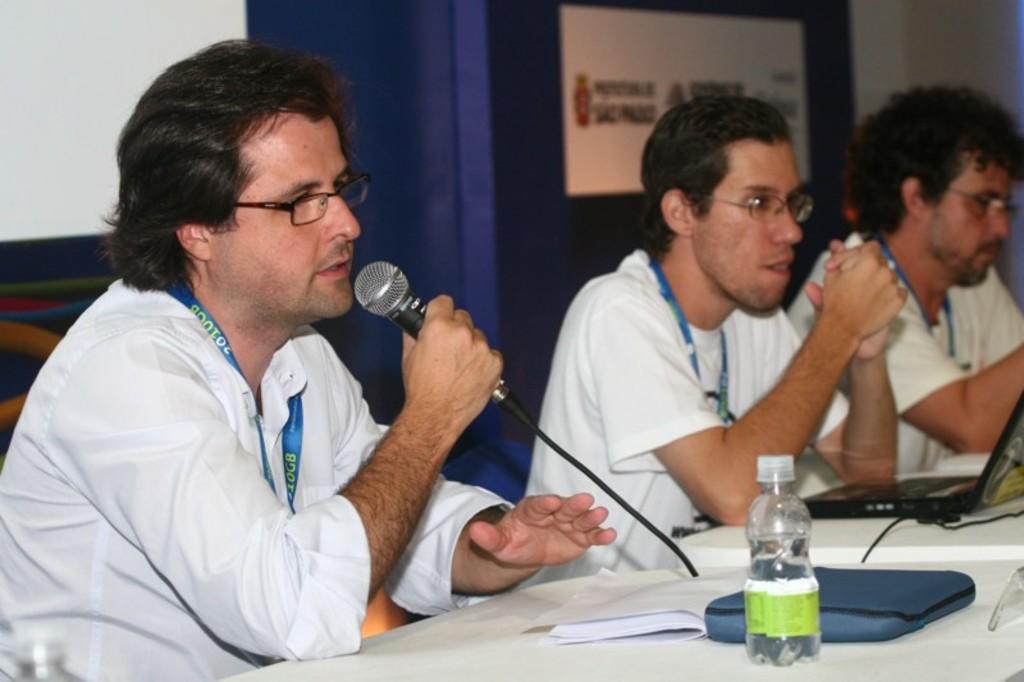How would you summarize this image in a sentence or two? In this image we can see some people sitting wearing lanyards. And we can see a microphone in one of their hands. And we can see laptops, bottles and some other objects on the white surface. And in the background, we can see some boards and the screen. 